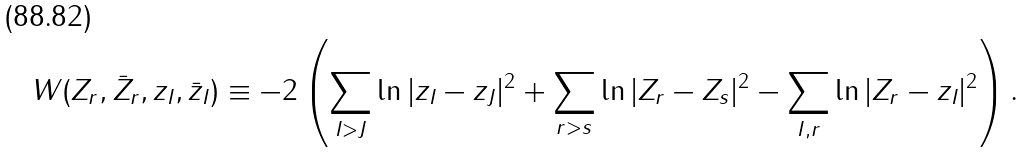<formula> <loc_0><loc_0><loc_500><loc_500>W ( Z _ { r } , \bar { Z } _ { r } , z _ { I } , \bar { z } _ { I } ) \equiv - 2 \left ( \sum _ { I > J } \ln | z _ { I } - z _ { J } | ^ { 2 } + \sum _ { r > s } \ln | Z _ { r } - Z _ { s } | ^ { 2 } - \sum _ { I , r } \ln | Z _ { r } - z _ { I } | ^ { 2 } \right ) .</formula> 